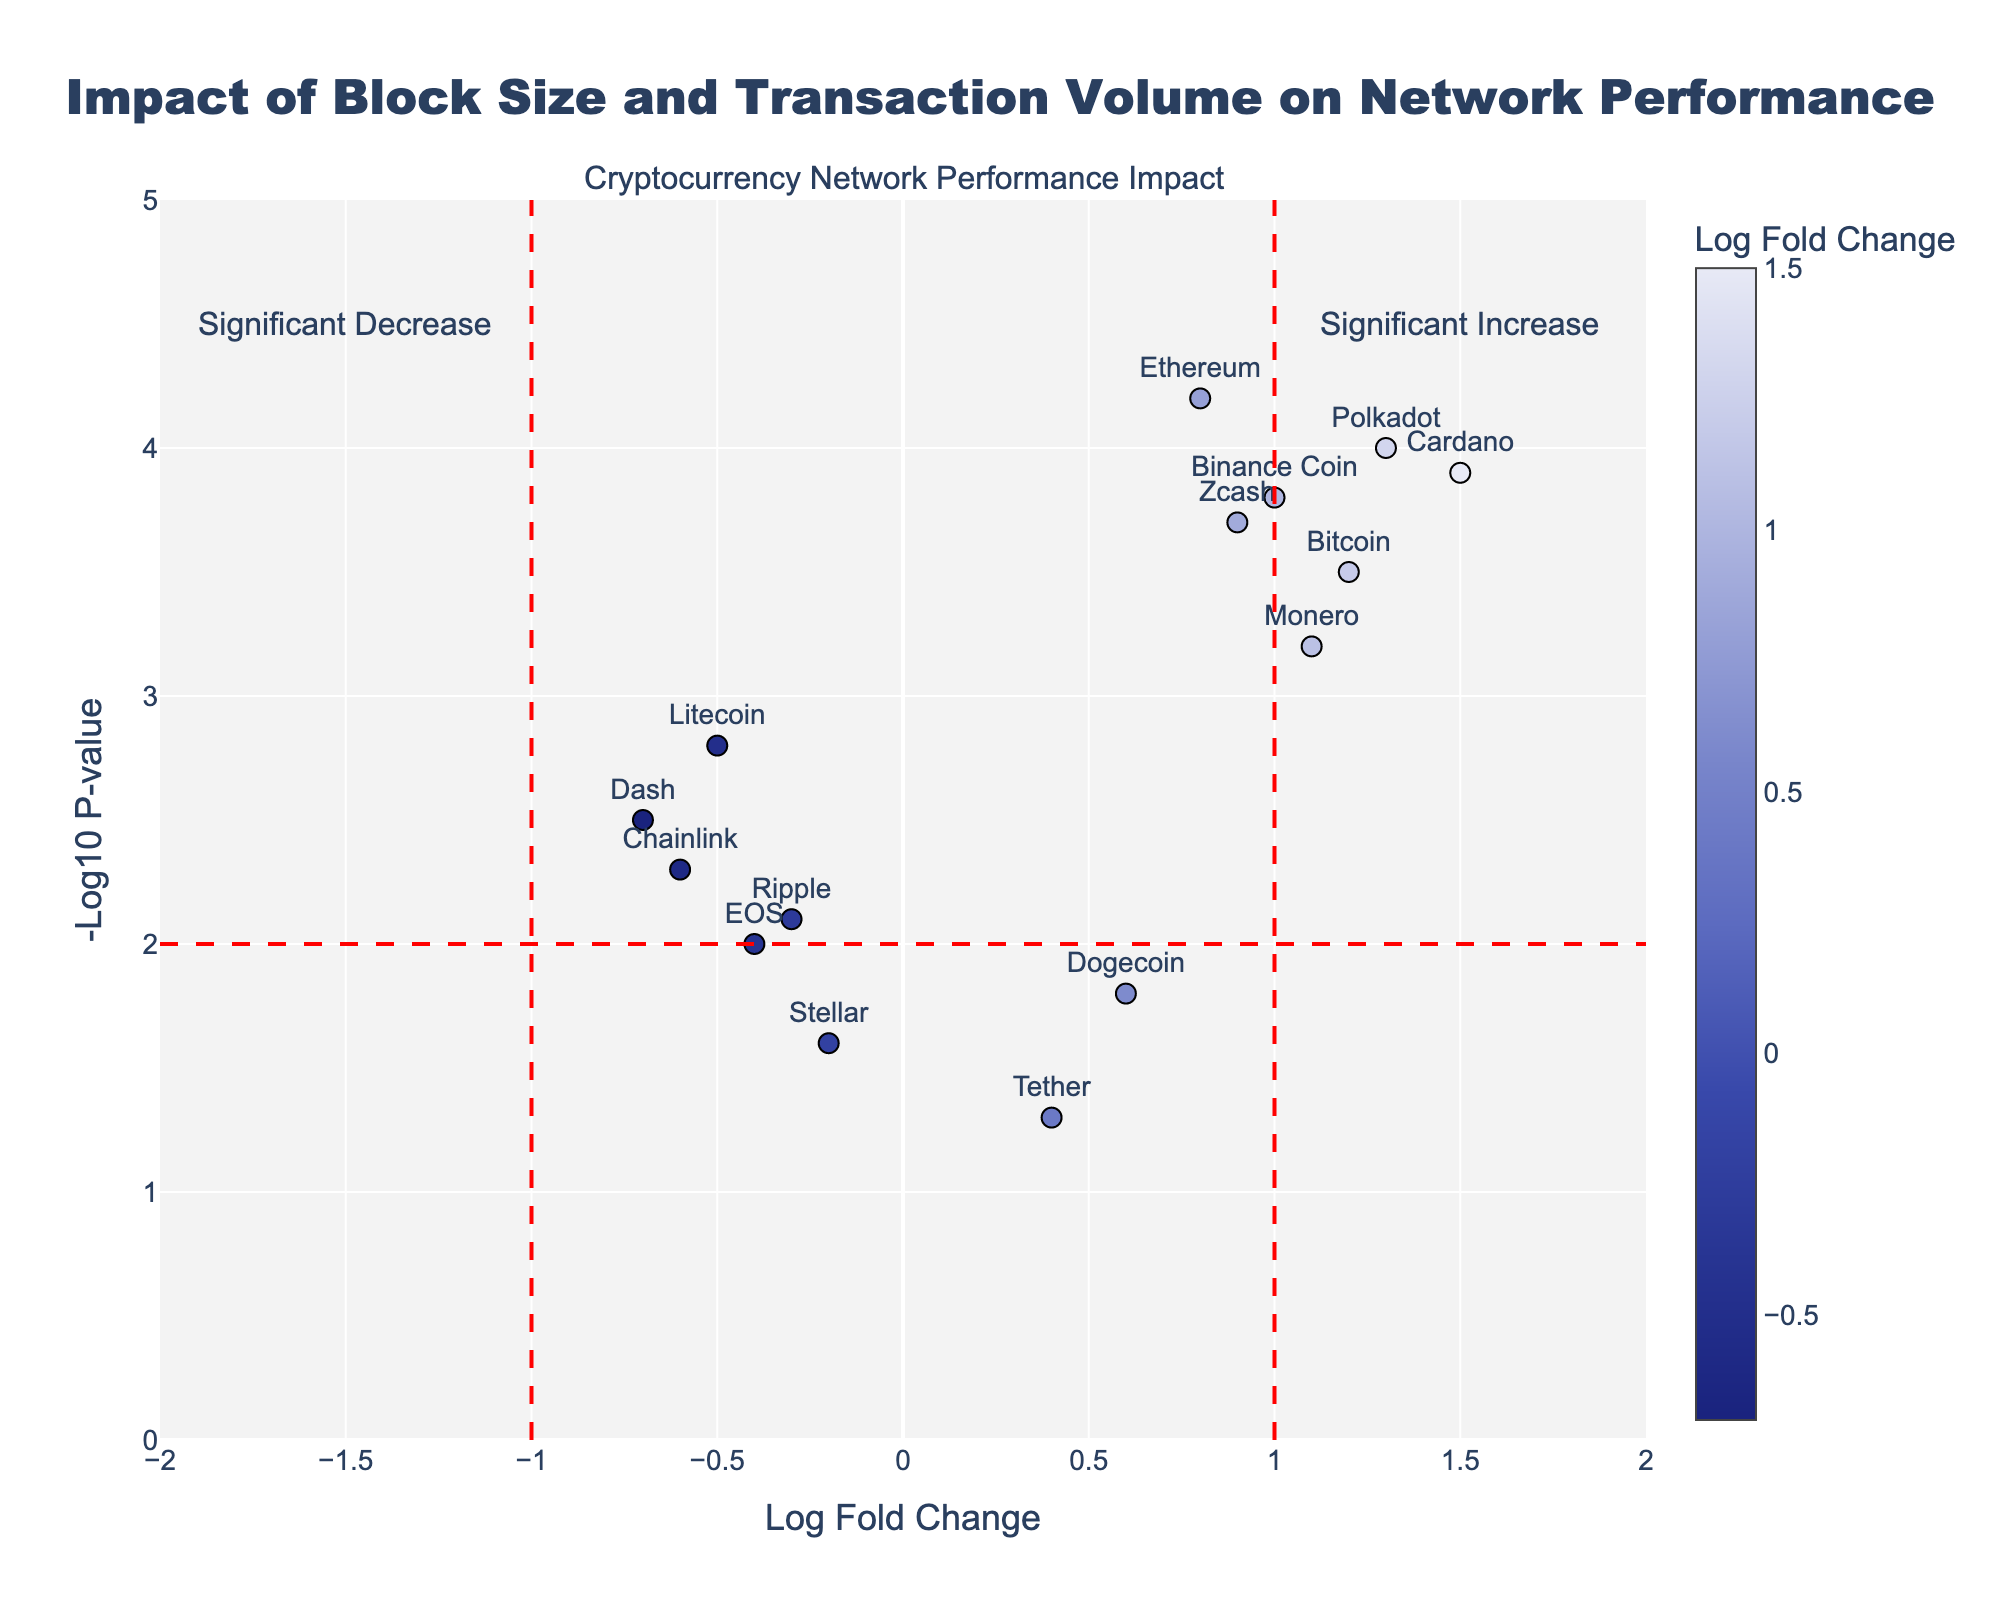Which cryptocurrency has the highest Log Fold Change? To determine the highest Log Fold Change, observe the x-axis values and find the cryptocurrency located furthest to the right on the plot.
Answer: Cardano Which cryptocurrency has the lowest -Log10 P-value? Check the y-axis values to find the cryptocurrency positioned closest to the bottom of the plot.
Answer: Tether How many cryptocurrencies have a Log Fold Change greater than 1? Identify the data points to the right of the vertical line at x=1. Count those data points.
Answer: 4 Which cryptocurrency is associated with a significant decrease in network performance? Look for a data point with a negative Log Fold Change (left side of the plot) and a negative Log10 P-value higher than 2.
Answer: Dash How many cryptocurrencies are labeled on the plot? Count the number of distinct cryptocurrencies mentioned near the data points.
Answer: 15 Which cryptocurrencies fall into the category of "Significant Increase"? Identify cryptocurrencies that are to the right of the x=1 line and above the y=2 line.
Answer: Bitcoin, Ethereum, Cardano, Polkadot, Binance Coin What's the range of the Log Fold Change values in the plot? Identify the minimum and maximum x-axis values where the data points are present. The range is from the lowest to the highest values of the Log Fold Change.
Answer: -0.7 to 1.5 Compare the Network Performance Impact of Bitcoin and Litecoin. Look at the positions of Bitcoin and Litecoin on the plot. Bitcoin (x=1.2, y=3.5) is towards the right and high, indicating a significant increase. Litecoin (x=-0.5, y=2.8) is to the left and lower, indicating a decrease.
Answer: Bitcoin shows a significant increase while Litecoin shows a decrease Which cryptocurrency has the highest -Log10 P-value and what is its Log Fold Change? Find the highest data point on the y-axis, check the cryptocurrency and its associated x-axis value.
Answer: Ethereum, 0.8 